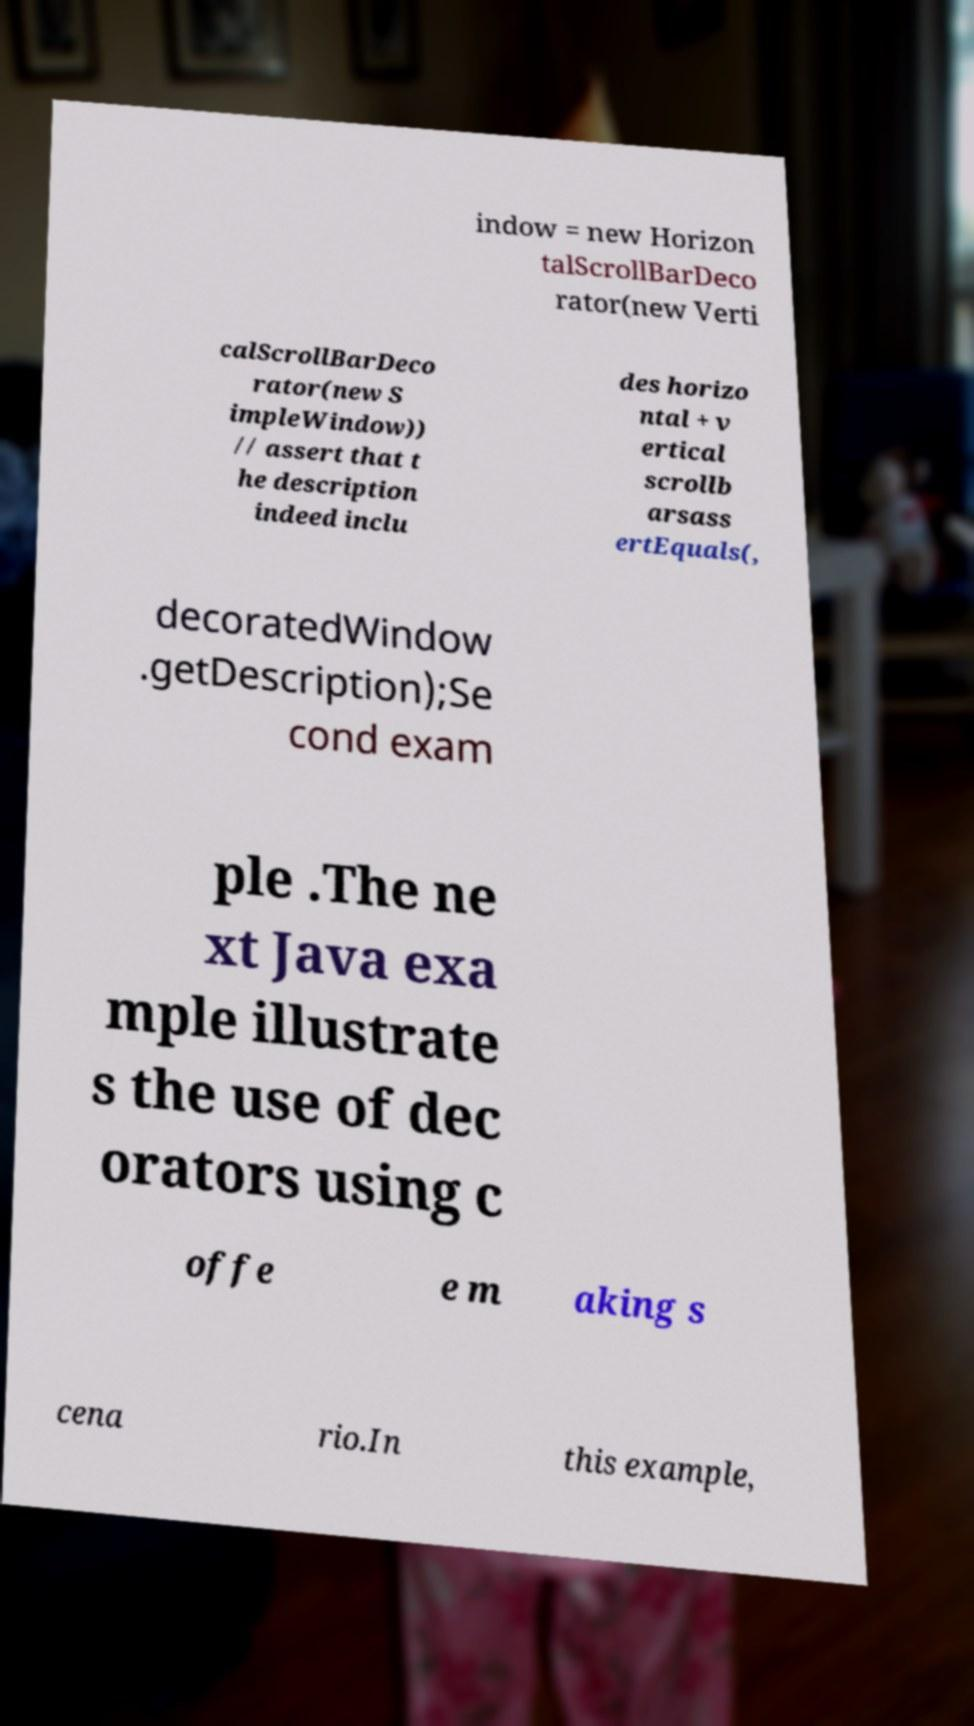Can you read and provide the text displayed in the image?This photo seems to have some interesting text. Can you extract and type it out for me? indow = new Horizon talScrollBarDeco rator(new Verti calScrollBarDeco rator(new S impleWindow)) // assert that t he description indeed inclu des horizo ntal + v ertical scrollb arsass ertEquals(, decoratedWindow .getDescription);Se cond exam ple .The ne xt Java exa mple illustrate s the use of dec orators using c offe e m aking s cena rio.In this example, 